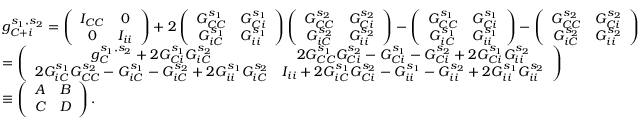Convert formula to latex. <formula><loc_0><loc_0><loc_500><loc_500>\begin{array} { r l } & { g _ { C + i } ^ { s _ { 1 } , s _ { 2 } } = \left ( \begin{array} { c c } { I _ { C C } } & { 0 } \\ { 0 } & { I _ { i i } } \end{array} \right ) + 2 \left ( \begin{array} { c c } { G _ { C C } ^ { s _ { 1 } } } & { G _ { C i } ^ { s _ { 1 } } } \\ { G _ { i C } ^ { s _ { 1 } } } & { G _ { i i } ^ { s _ { 1 } } } \end{array} \right ) \left ( \begin{array} { c c } { G _ { C C } ^ { s _ { 2 } } } & { G _ { C i } ^ { s _ { 2 } } } \\ { G _ { i C } ^ { s _ { 2 } } } & { G _ { i i } ^ { s _ { 2 } } } \end{array} \right ) - \left ( \begin{array} { c c } { G _ { C C } ^ { s _ { 1 } } } & { G _ { C i } ^ { s _ { 1 } } } \\ { G _ { i C } ^ { s _ { 1 } } } & { G _ { i i } ^ { s _ { 1 } } } \end{array} \right ) - \left ( \begin{array} { c c } { G _ { C C } ^ { s _ { 2 } } } & { G _ { C i } ^ { s _ { 2 } } } \\ { G _ { i C } ^ { s _ { 2 } } } & { G _ { i i } ^ { s _ { 2 } } } \end{array} \right ) } \\ & { = \left ( \begin{array} { c c } { g _ { C } ^ { s _ { 1 } , s _ { 2 } } + 2 G _ { C i } ^ { s _ { 1 } } G _ { i C } ^ { s _ { 2 } } } & { 2 G _ { C C } ^ { s _ { 1 } } G _ { C i } ^ { s _ { 2 } } - G _ { C i } ^ { s _ { 1 } } - G _ { C i } ^ { s _ { 2 } } + 2 G _ { C i } ^ { s _ { 1 } } G _ { i i } ^ { s _ { 2 } } } \\ { 2 G _ { i C } ^ { s _ { 1 } } G _ { C C } ^ { s _ { 2 } } - G _ { i C } ^ { s _ { 1 } } - G _ { i C } ^ { s _ { 2 } } + 2 G _ { i i } ^ { s _ { 1 } } G _ { i C } ^ { s _ { 2 } } } & { I _ { i i } + 2 G _ { i C } ^ { s _ { 1 } } G _ { C i } ^ { s _ { 2 } } - G _ { i i } ^ { s _ { 1 } } - G _ { i i } ^ { s _ { 2 } } + 2 G _ { i i } ^ { s _ { 1 } } G _ { i i } ^ { s _ { 2 } } } \end{array} \right ) } \\ & { \equiv \left ( \begin{array} { c c } { A } & { B } \\ { C } & { D } \end{array} \right ) . } \end{array}</formula> 